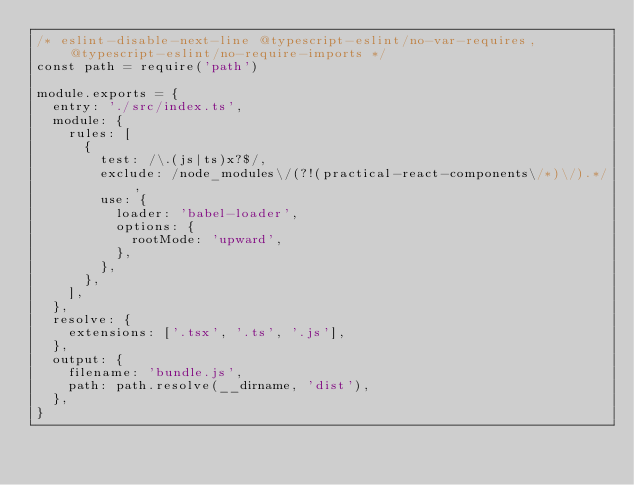Convert code to text. <code><loc_0><loc_0><loc_500><loc_500><_JavaScript_>/* eslint-disable-next-line @typescript-eslint/no-var-requires, @typescript-eslint/no-require-imports */
const path = require('path')

module.exports = {
  entry: './src/index.ts',
  module: {
    rules: [
      {
        test: /\.(js|ts)x?$/,
        exclude: /node_modules\/(?!(practical-react-components\/*)\/).*/,
        use: {
          loader: 'babel-loader',
          options: {
            rootMode: 'upward',
          },
        },
      },
    ],
  },
  resolve: {
    extensions: ['.tsx', '.ts', '.js'],
  },
  output: {
    filename: 'bundle.js',
    path: path.resolve(__dirname, 'dist'),
  },
}
</code> 